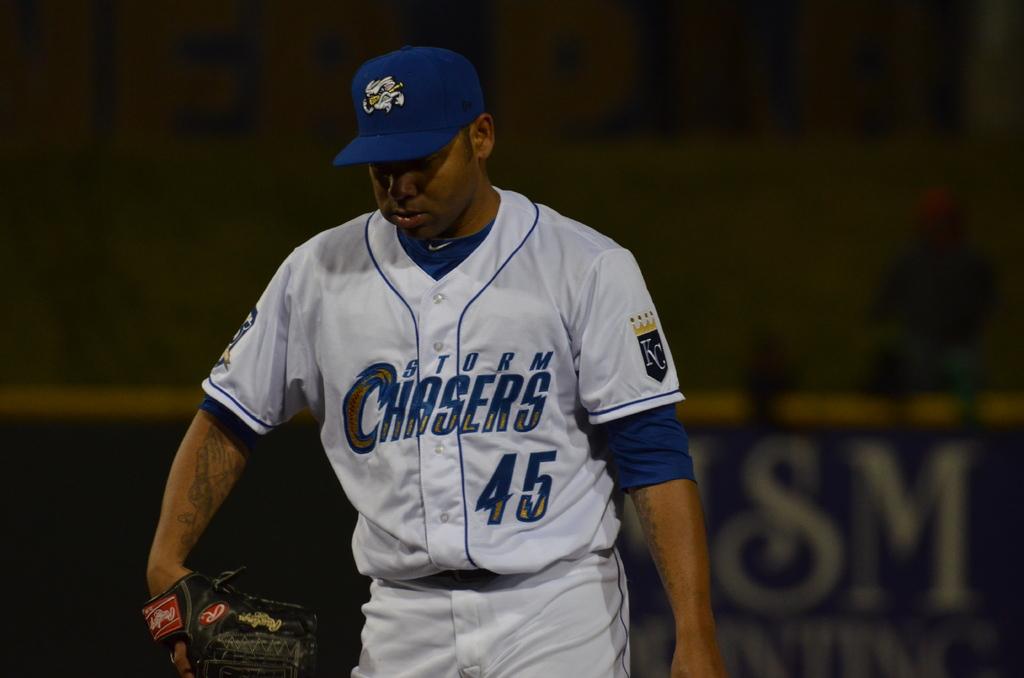What is the team name on the players jersey?
Make the answer very short. Storm chasers. What is the players number?
Provide a succinct answer. 45. 